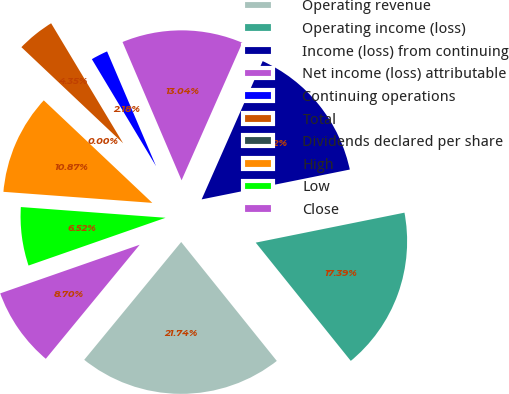<chart> <loc_0><loc_0><loc_500><loc_500><pie_chart><fcel>Operating revenue<fcel>Operating income (loss)<fcel>Income (loss) from continuing<fcel>Net income (loss) attributable<fcel>Continuing operations<fcel>Total<fcel>Dividends declared per share<fcel>High<fcel>Low<fcel>Close<nl><fcel>21.74%<fcel>17.39%<fcel>15.22%<fcel>13.04%<fcel>2.18%<fcel>4.35%<fcel>0.0%<fcel>10.87%<fcel>6.52%<fcel>8.7%<nl></chart> 